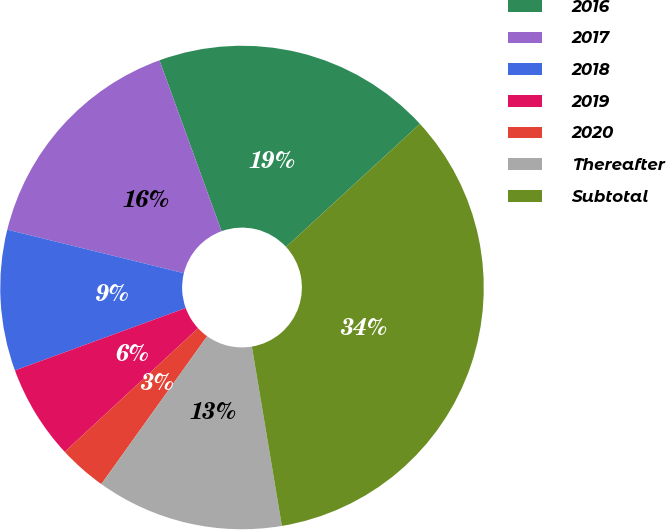Convert chart to OTSL. <chart><loc_0><loc_0><loc_500><loc_500><pie_chart><fcel>2016<fcel>2017<fcel>2018<fcel>2019<fcel>2020<fcel>Thereafter<fcel>Subtotal<nl><fcel>18.71%<fcel>15.61%<fcel>9.42%<fcel>6.32%<fcel>3.22%<fcel>12.52%<fcel>34.2%<nl></chart> 